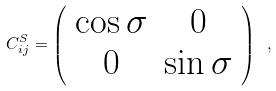Convert formula to latex. <formula><loc_0><loc_0><loc_500><loc_500>C ^ { S } _ { i j } = \left ( \begin{array} { c c } \cos { \sigma } & 0 \\ 0 & \sin { \sigma } \end{array} \right ) \ ,</formula> 